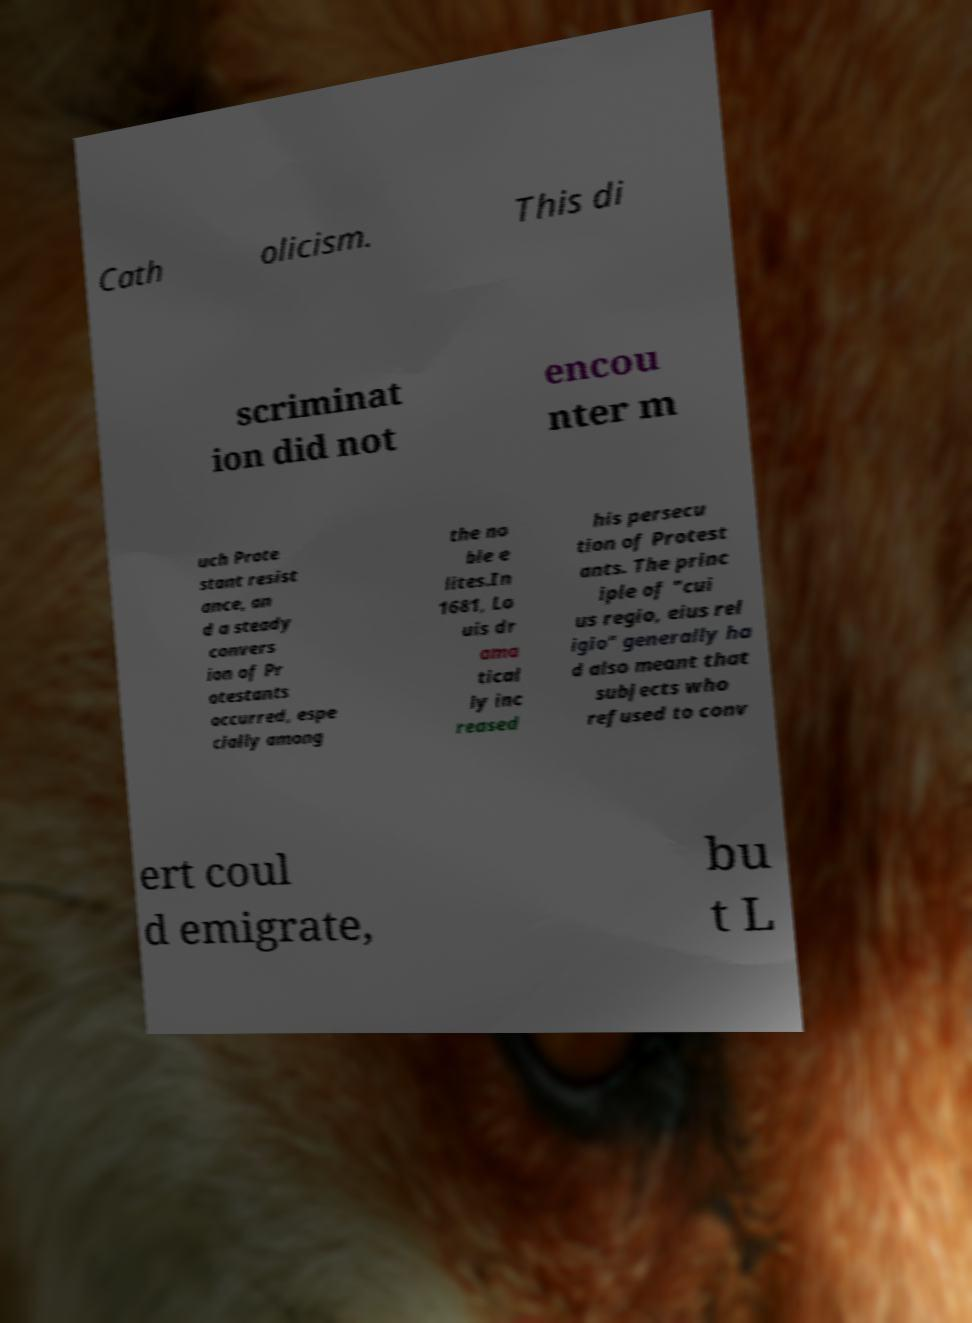There's text embedded in this image that I need extracted. Can you transcribe it verbatim? Cath olicism. This di scriminat ion did not encou nter m uch Prote stant resist ance, an d a steady convers ion of Pr otestants occurred, espe cially among the no ble e lites.In 1681, Lo uis dr ama tical ly inc reased his persecu tion of Protest ants. The princ iple of "cui us regio, eius rel igio" generally ha d also meant that subjects who refused to conv ert coul d emigrate, bu t L 